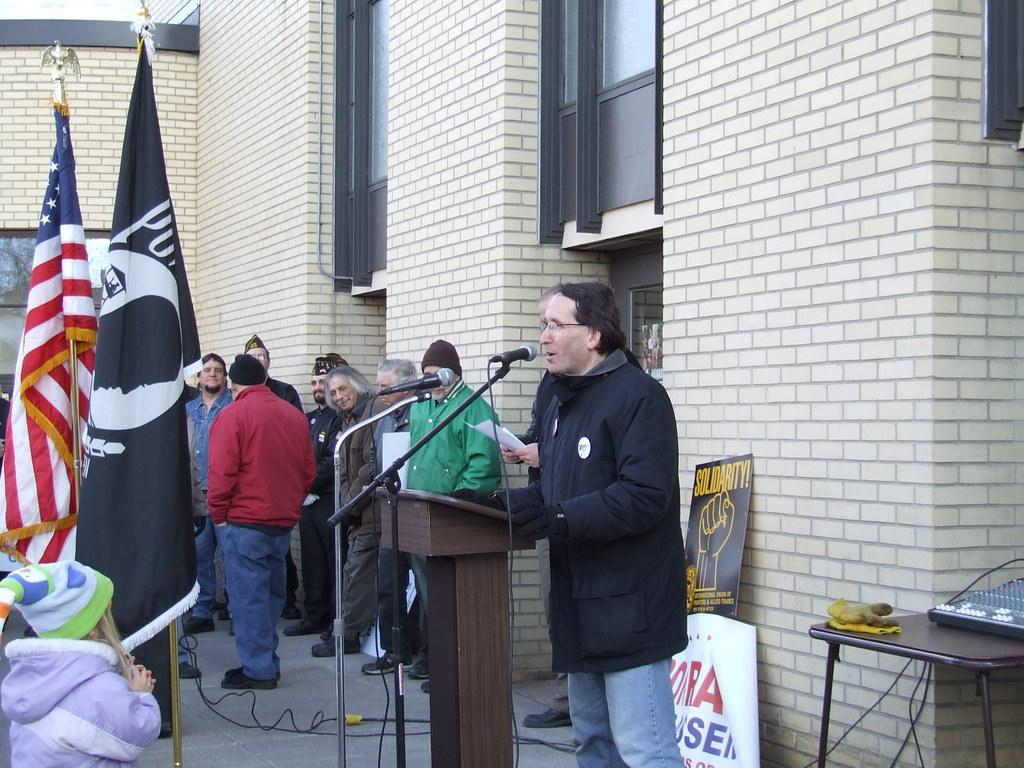What type of structures can be seen in the image? There are buildings in the image. What decorative elements are present in the image? There are flags in the image. What devices are visible in the image? There are microphones (mics) in the image. What type of signage is present in the image? There is a banner in the image. What piece of furniture is visible in the image? There is a table in the image. Who or what is present in the image? There are people in the image. What type of soup is being served on the table in the image? There is no soup present in the image; the table is not associated with any food or beverages. What type of sticks are being used by the people in the image? There are no sticks visible in the image; the people are not holding or using any sticks. 